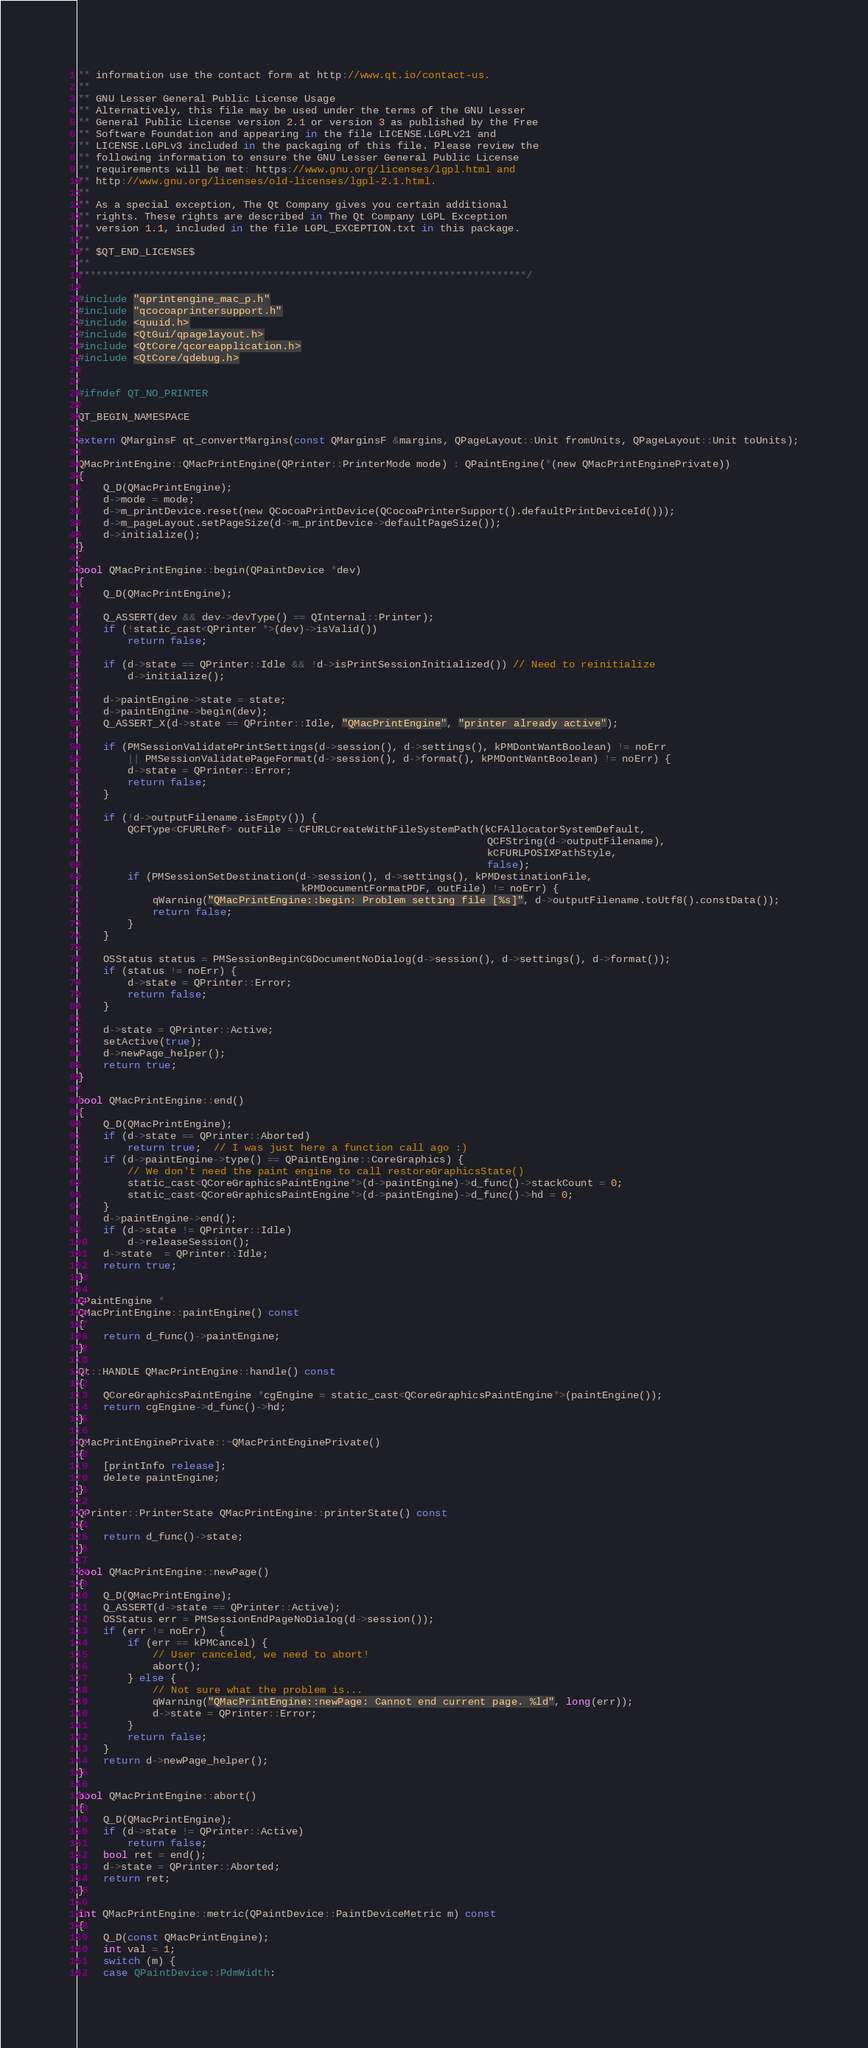Convert code to text. <code><loc_0><loc_0><loc_500><loc_500><_ObjectiveC_>** information use the contact form at http://www.qt.io/contact-us.
**
** GNU Lesser General Public License Usage
** Alternatively, this file may be used under the terms of the GNU Lesser
** General Public License version 2.1 or version 3 as published by the Free
** Software Foundation and appearing in the file LICENSE.LGPLv21 and
** LICENSE.LGPLv3 included in the packaging of this file. Please review the
** following information to ensure the GNU Lesser General Public License
** requirements will be met: https://www.gnu.org/licenses/lgpl.html and
** http://www.gnu.org/licenses/old-licenses/lgpl-2.1.html.
**
** As a special exception, The Qt Company gives you certain additional
** rights. These rights are described in The Qt Company LGPL Exception
** version 1.1, included in the file LGPL_EXCEPTION.txt in this package.
**
** $QT_END_LICENSE$
**
****************************************************************************/

#include "qprintengine_mac_p.h"
#include "qcocoaprintersupport.h"
#include <quuid.h>
#include <QtGui/qpagelayout.h>
#include <QtCore/qcoreapplication.h>
#include <QtCore/qdebug.h>


#ifndef QT_NO_PRINTER

QT_BEGIN_NAMESPACE

extern QMarginsF qt_convertMargins(const QMarginsF &margins, QPageLayout::Unit fromUnits, QPageLayout::Unit toUnits);

QMacPrintEngine::QMacPrintEngine(QPrinter::PrinterMode mode) : QPaintEngine(*(new QMacPrintEnginePrivate))
{
    Q_D(QMacPrintEngine);
    d->mode = mode;
    d->m_printDevice.reset(new QCocoaPrintDevice(QCocoaPrinterSupport().defaultPrintDeviceId()));
    d->m_pageLayout.setPageSize(d->m_printDevice->defaultPageSize());
    d->initialize();
}

bool QMacPrintEngine::begin(QPaintDevice *dev)
{
    Q_D(QMacPrintEngine);

    Q_ASSERT(dev && dev->devType() == QInternal::Printer);
    if (!static_cast<QPrinter *>(dev)->isValid())
        return false;

    if (d->state == QPrinter::Idle && !d->isPrintSessionInitialized()) // Need to reinitialize
        d->initialize();

    d->paintEngine->state = state;
    d->paintEngine->begin(dev);
    Q_ASSERT_X(d->state == QPrinter::Idle, "QMacPrintEngine", "printer already active");

    if (PMSessionValidatePrintSettings(d->session(), d->settings(), kPMDontWantBoolean) != noErr
        || PMSessionValidatePageFormat(d->session(), d->format(), kPMDontWantBoolean) != noErr) {
        d->state = QPrinter::Error;
        return false;
    }

    if (!d->outputFilename.isEmpty()) {
        QCFType<CFURLRef> outFile = CFURLCreateWithFileSystemPath(kCFAllocatorSystemDefault,
                                                                  QCFString(d->outputFilename),
                                                                  kCFURLPOSIXPathStyle,
                                                                  false);
        if (PMSessionSetDestination(d->session(), d->settings(), kPMDestinationFile,
                                    kPMDocumentFormatPDF, outFile) != noErr) {
            qWarning("QMacPrintEngine::begin: Problem setting file [%s]", d->outputFilename.toUtf8().constData());
            return false;
        }
    }

    OSStatus status = PMSessionBeginCGDocumentNoDialog(d->session(), d->settings(), d->format());
    if (status != noErr) {
        d->state = QPrinter::Error;
        return false;
    }

    d->state = QPrinter::Active;
    setActive(true);
    d->newPage_helper();
    return true;
}

bool QMacPrintEngine::end()
{
    Q_D(QMacPrintEngine);
    if (d->state == QPrinter::Aborted)
        return true;  // I was just here a function call ago :)
    if (d->paintEngine->type() == QPaintEngine::CoreGraphics) {
        // We don't need the paint engine to call restoreGraphicsState()
        static_cast<QCoreGraphicsPaintEngine*>(d->paintEngine)->d_func()->stackCount = 0;
        static_cast<QCoreGraphicsPaintEngine*>(d->paintEngine)->d_func()->hd = 0;
    }
    d->paintEngine->end();
    if (d->state != QPrinter::Idle)
        d->releaseSession();
    d->state  = QPrinter::Idle;
    return true;
}

QPaintEngine *
QMacPrintEngine::paintEngine() const
{
    return d_func()->paintEngine;
}

Qt::HANDLE QMacPrintEngine::handle() const
{
    QCoreGraphicsPaintEngine *cgEngine = static_cast<QCoreGraphicsPaintEngine*>(paintEngine());
    return cgEngine->d_func()->hd;
}

QMacPrintEnginePrivate::~QMacPrintEnginePrivate()
{
    [printInfo release];
    delete paintEngine;
}

QPrinter::PrinterState QMacPrintEngine::printerState() const
{
    return d_func()->state;
}

bool QMacPrintEngine::newPage()
{
    Q_D(QMacPrintEngine);
    Q_ASSERT(d->state == QPrinter::Active);
    OSStatus err = PMSessionEndPageNoDialog(d->session());
    if (err != noErr)  {
        if (err == kPMCancel) {
            // User canceled, we need to abort!
            abort();
        } else {
            // Not sure what the problem is...
            qWarning("QMacPrintEngine::newPage: Cannot end current page. %ld", long(err));
            d->state = QPrinter::Error;
        }
        return false;
    }
    return d->newPage_helper();
}

bool QMacPrintEngine::abort()
{
    Q_D(QMacPrintEngine);
    if (d->state != QPrinter::Active)
        return false;
    bool ret = end();
    d->state = QPrinter::Aborted;
    return ret;
}

int QMacPrintEngine::metric(QPaintDevice::PaintDeviceMetric m) const
{
    Q_D(const QMacPrintEngine);
    int val = 1;
    switch (m) {
    case QPaintDevice::PdmWidth:</code> 